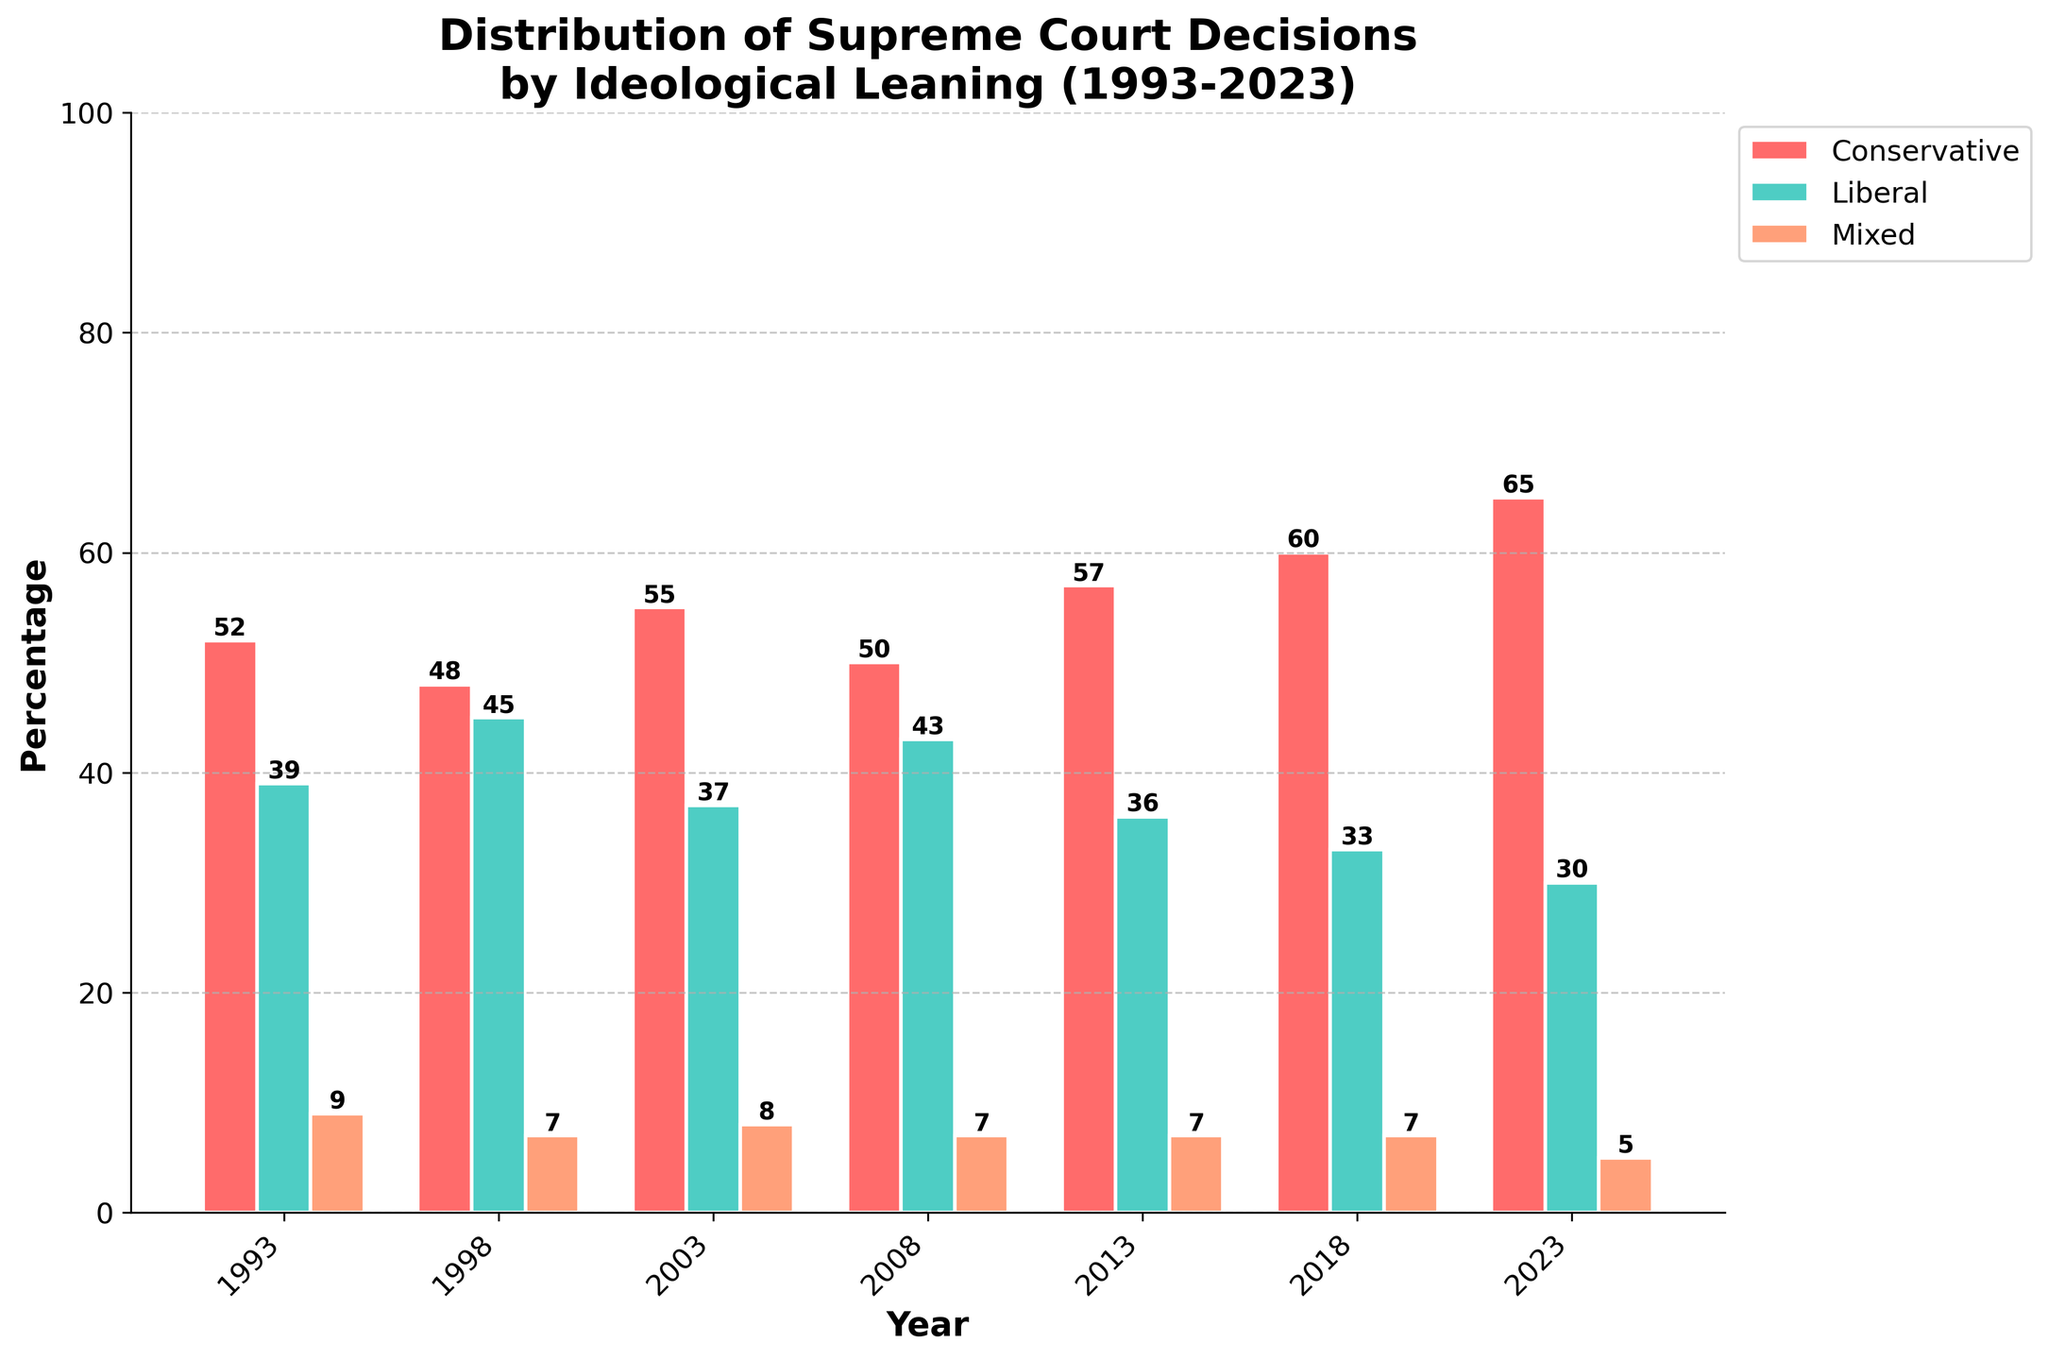Which year had the highest proportion of conservative Supreme Court decisions? The highest bar in the conservative category is the red bar for the year 2023, with a value of 65.
Answer: 2023 How did the percentage of liberal decisions change from 1993 to 2023? In 1993, the percentage of liberal decisions was 39. In 2023, it was 30. The change is 30 - 39, which is a decrease of 9 percentage points.
Answer: Decreased by 9 percentage points What is the average percentage of mixed decisions over the three decades represented? The mixed percentages are 9, 7, 8, 7, 7, 7, and 5. The sum is 50. The average is 50/7 = approximately 7.14.
Answer: Approximately 7.14 By how many percentage points did conservative decisions increase from 1993 to 2018? Conservative decisions in 1993 were 52, and in 2018 it was 60. The increase is 60 - 52 = 8 percentage points.
Answer: 8 percentage points Which ideological leaning had the smallest variation over the years? Conservative decisions range from 48 to 65 (variation of 17 percentage points), liberal from 30 to 45 (variation of 15 percentage points), and mixed from 5 to 9 (variation of 4 percentage points). The smallest variation is in mixed decisions.
Answer: Mixed In which year did mixed decisions account for exactly 7% of the total decisions? The eye can see that the orange bars (mixed decisions) reach the 7% mark in the years 1998, 2008, 2013, and 2018.
Answer: 1998, 2008, 2013, and 2018 Compare the overall trend of conservative and liberal decisions from 1993 to 2023. Conservative decisions show an increasing trend from 52 in 1993 to 65 in 2023. On the other hand, liberal decisions show a decreasing trend from 39 in 1993 to 30 in 2023.
Answer: Conservative increased, Liberal decreased What is the combined percentage of conservative and liberal decisions in 2013? In 2013, the conservative decisions were 57 and the liberal decisions were 36. The combined percentage is 57 + 36 = 93.
Answer: 93 Which year had the closest percentages of conservative and liberal decisions, and what are those percentages? By inspecting the bars, the year 1998 shows conservative at 48 and liberal at 45, which are the closest among the entries. The difference is 3 percentage points.
Answer: 1998, Conservative: 48, Liberal: 45 What were the conservative and liberal decisions percentages in 2008, and how do their sums compare to that of mixed decisions in the same year? In 2008, conservative decisions were 50%, and liberal decisions were 43%. Their sum is 50 + 43 = 93. Mixed decisions in 2008 were 7%. Thus, 93 is significantly greater than 7.
Answer: Conservative: 50, Liberal: 43, Sum: 93, Mixed: 7 